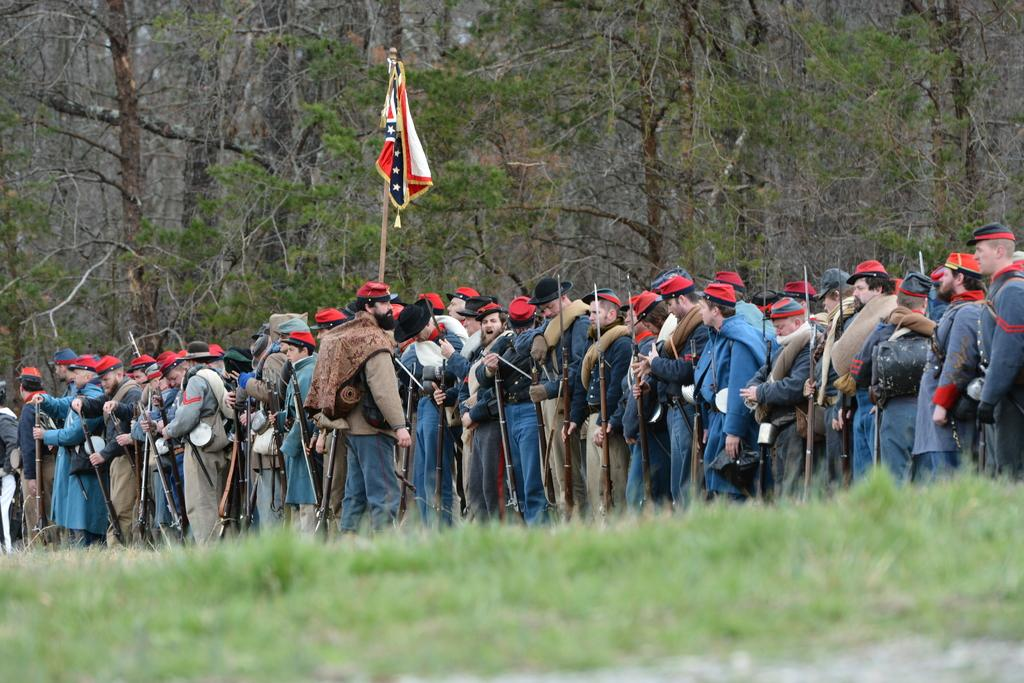What is the main subject of the image? The main subject of the image is a group of people. What are the people in the image doing? The people are standing and holding guns. What can be seen in the background of the image? There are trees in the background of the image. What type of cheese is being discussed by the committee in the image? There is no committee or cheese present in the image; it features a group of people standing and holding guns. 